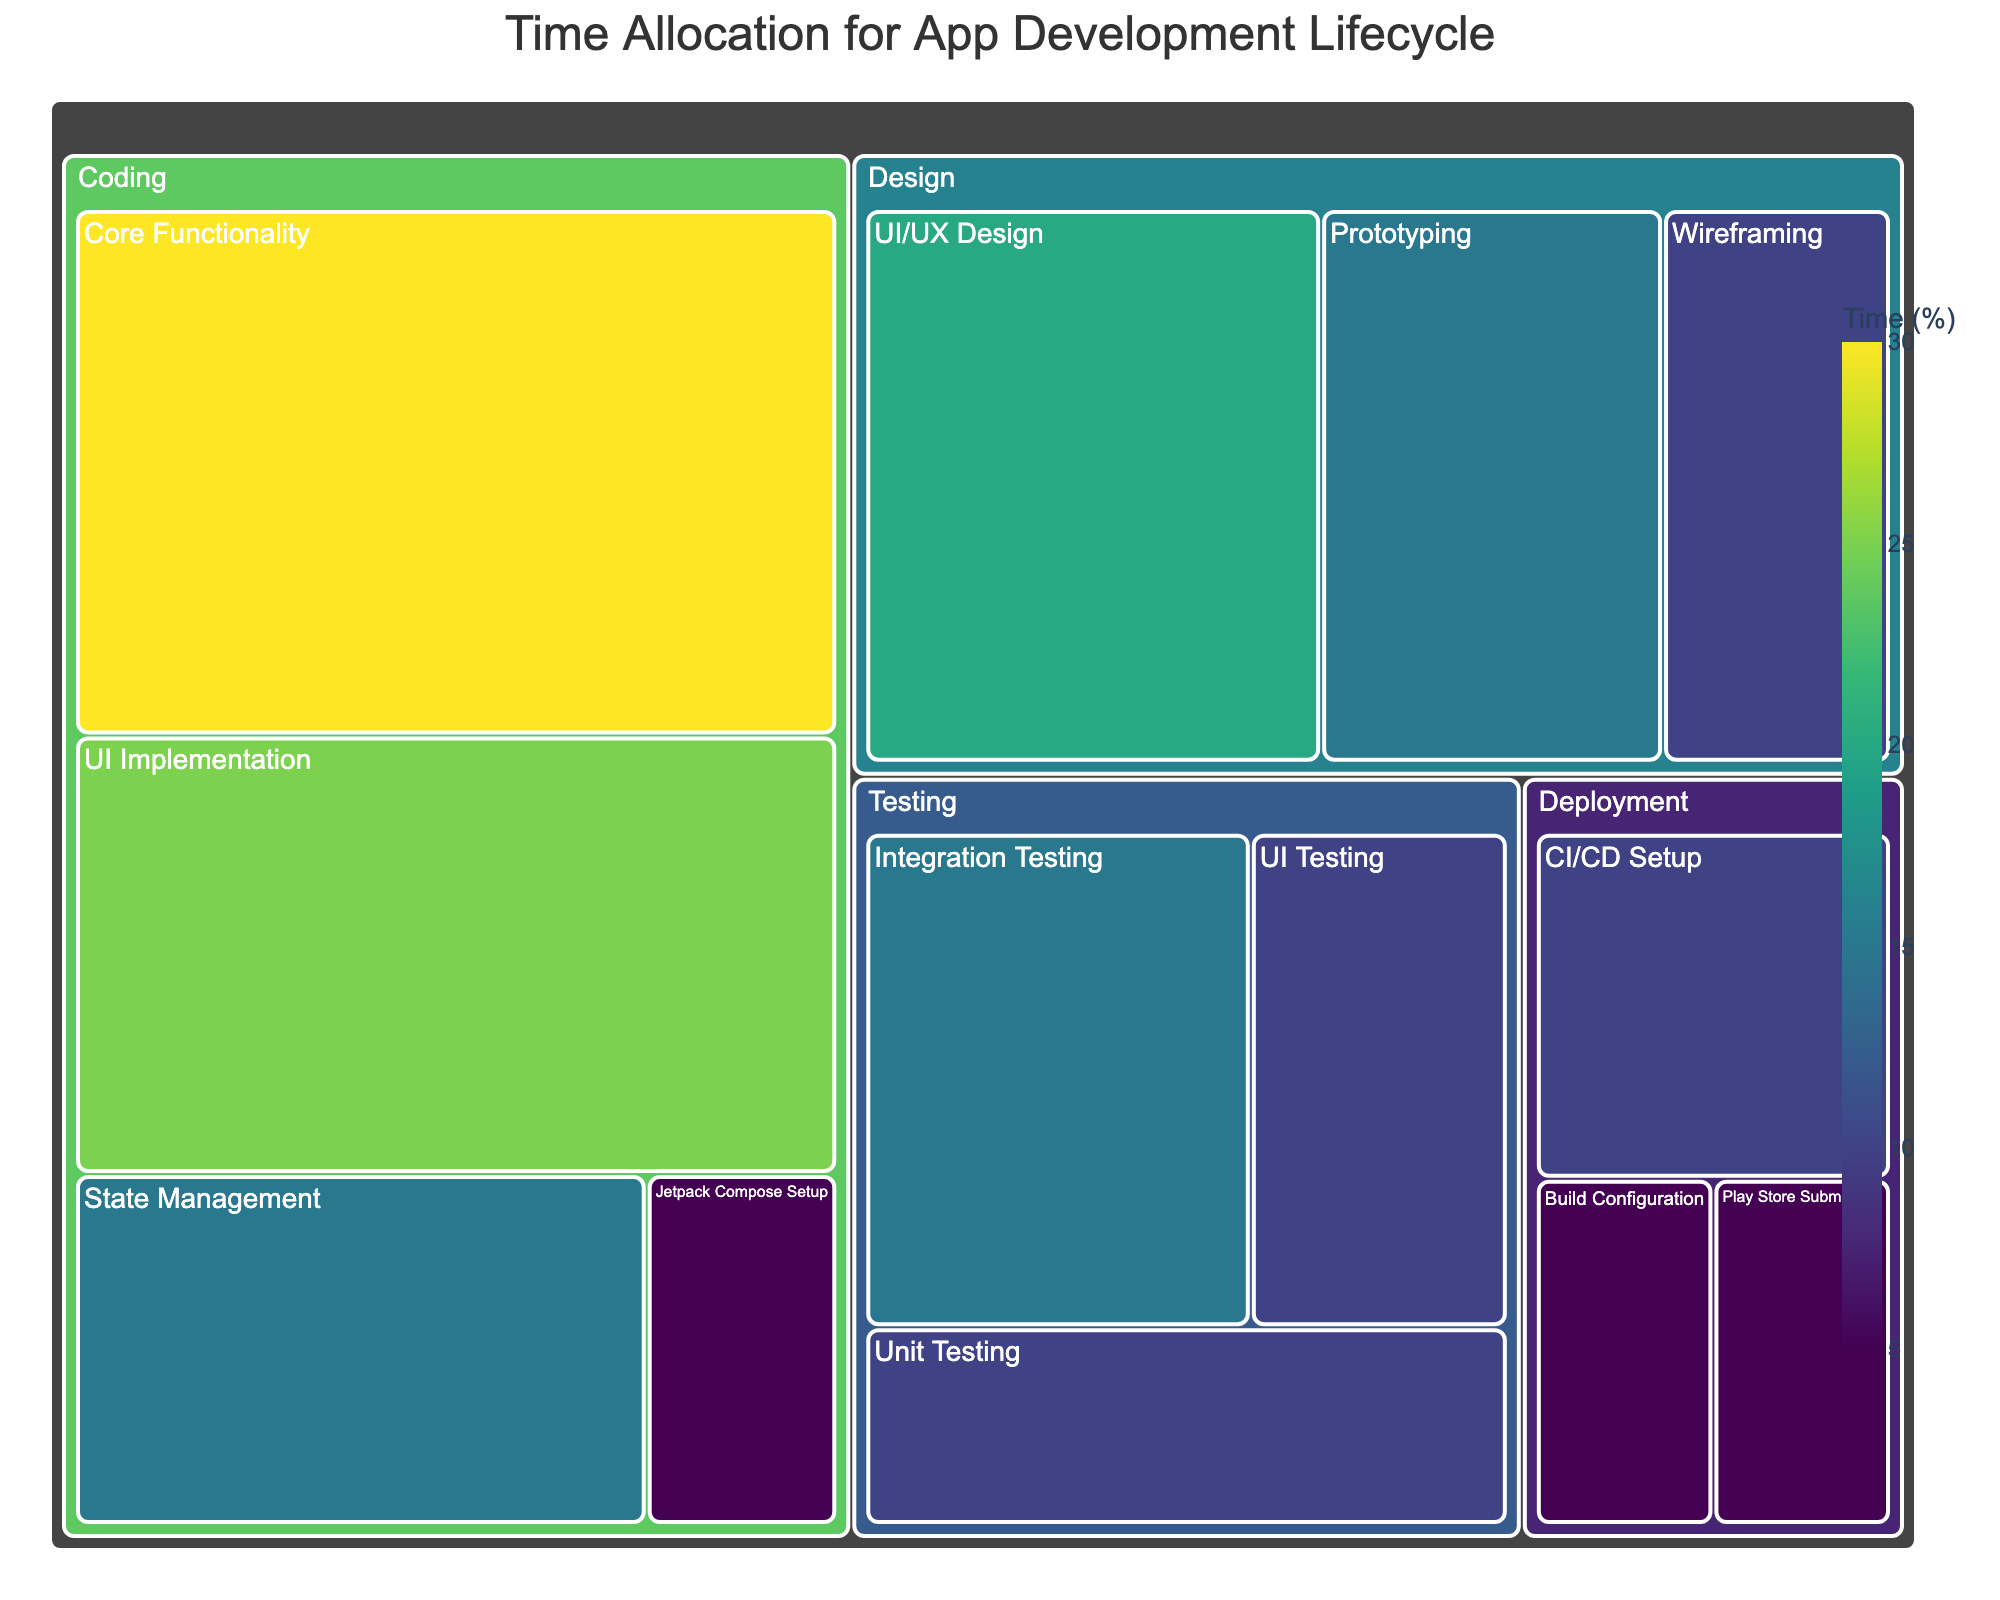What's the title of the figure? The title is typically displayed at the top of the figure. From the provided details, the title is "Time Allocation for App Development Lifecycle".
Answer: Time Allocation for App Development Lifecycle How much time is allocated to "Core Functionality"? Locate "Core Functionality" within the "Coding" category in the treemap. The value associated with it is 30%.
Answer: 30% Can you sum up the time spent on all "Testing" subcategories? Add up the values of all subcategories under "Testing". The values are 10 (Unit Testing) + 15 (Integration Testing) + 10 (UI Testing) = 35%.
Answer: 35% Which subcategory in "Design" takes the most time, and how much? Look at the values for subcategories under "Design". UI/UX Design has 20%, Wireframing has 10%, Prototyping has 15%. UI/UX Design is the highest.
Answer: UI/UX Design, 20% Compare the time allocated to "UI Implementation" and "State Management". Which one takes more time? Check the values of these subcategories under "Coding". UI Implementation has 25% and State Management has 15%. UI Implementation takes more time.
Answer: UI Implementation What's the least time-consuming subcategory overall, and what’s its value? Identify the subcategory with the smallest value in the treemap. "Jetpack Compose Setup" and "Play Store Submission" both consume the least time, which is 5%.
Answer: Jetpack Compose Setup and Play Store Submission, 5% How much more time is spent on "Integration Testing" compared to "UI Testing"? Find the values for both subcategories under "Testing". Integration Testing is 15% and UI Testing is 10%. 15% - 10% = 5%.
Answer: 5% What percentage of the total time is dedicated to the "Deployment" category? Add up the values of the subcategories under "Deployment". Build Configuration (5%) + Play Store Submission (5%) + CI/CD Setup (10%) = 20%.
Answer: 20% Which category has the highest total time allocation? Sum up the values of subcategories within each category. "Coding" has Jetpack Compose Setup (5%) + Core Functionality (30%) + UI Implementation (25%) + State Management (15%) = 75%. "Coding" has the highest allocation.
Answer: Coding What’s the total time allocation for the "Design" category? Add up the values of the subcategories under "Design". UI/UX Design (20%) + Wireframing (10%) + Prototyping (15%) = 45%.
Answer: 45% 